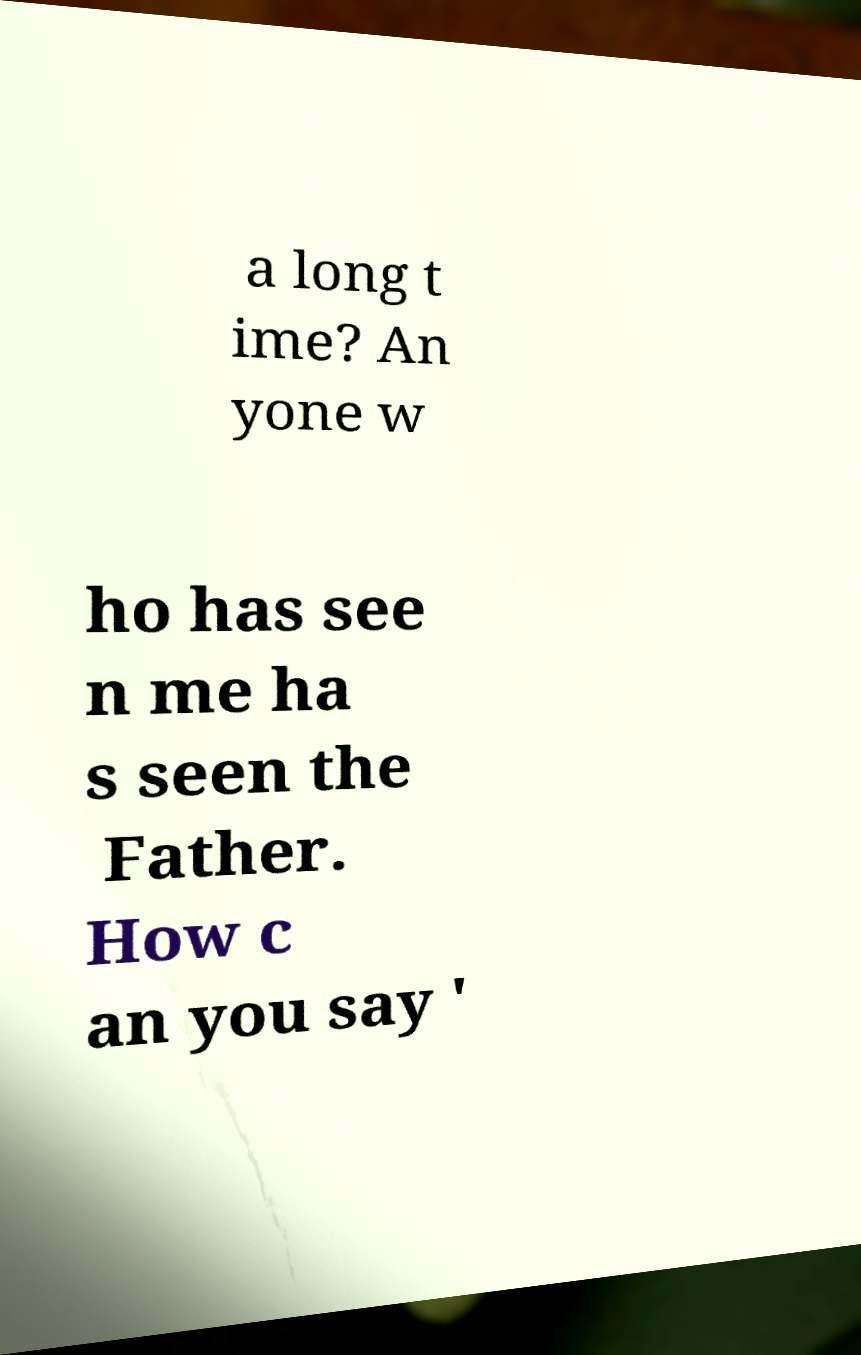Could you assist in decoding the text presented in this image and type it out clearly? a long t ime? An yone w ho has see n me ha s seen the Father. How c an you say ' 